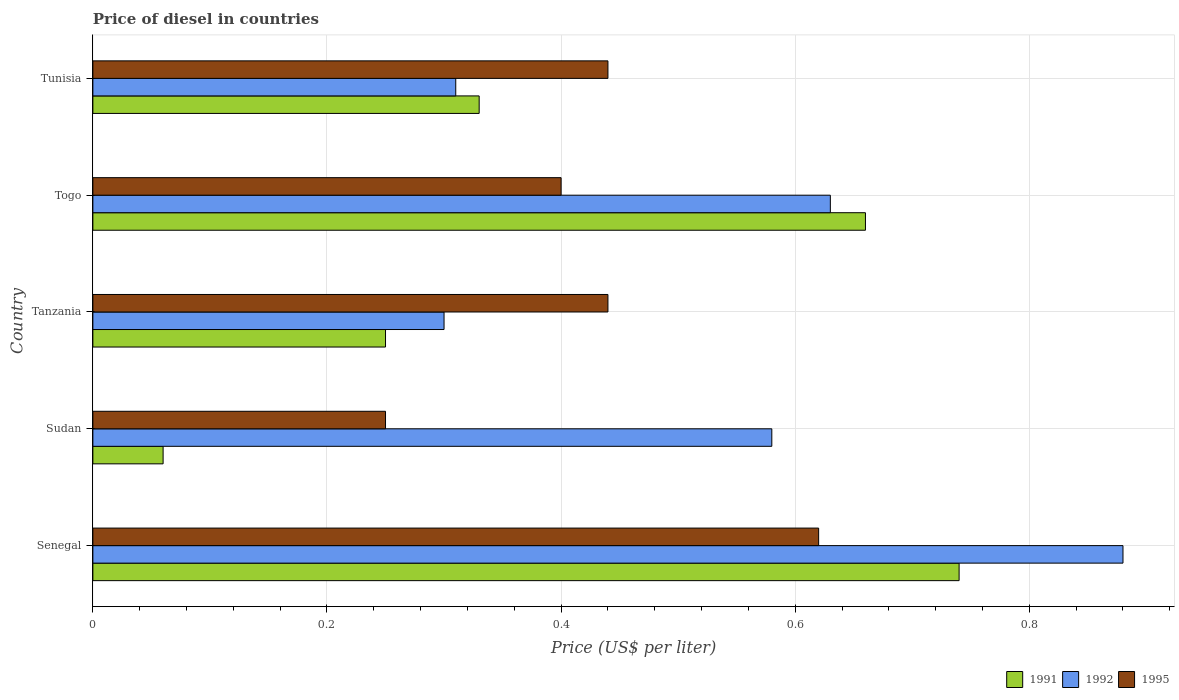How many different coloured bars are there?
Your response must be concise. 3. How many groups of bars are there?
Provide a succinct answer. 5. Are the number of bars per tick equal to the number of legend labels?
Your response must be concise. Yes. How many bars are there on the 1st tick from the bottom?
Give a very brief answer. 3. What is the label of the 1st group of bars from the top?
Offer a terse response. Tunisia. In how many cases, is the number of bars for a given country not equal to the number of legend labels?
Offer a very short reply. 0. What is the price of diesel in 1995 in Senegal?
Your answer should be very brief. 0.62. Across all countries, what is the maximum price of diesel in 1992?
Ensure brevity in your answer.  0.88. Across all countries, what is the minimum price of diesel in 1995?
Provide a short and direct response. 0.25. In which country was the price of diesel in 1992 maximum?
Your response must be concise. Senegal. In which country was the price of diesel in 1991 minimum?
Provide a short and direct response. Sudan. What is the total price of diesel in 1995 in the graph?
Offer a very short reply. 2.15. What is the difference between the price of diesel in 1992 in Senegal and that in Tanzania?
Offer a terse response. 0.58. What is the difference between the price of diesel in 1995 in Tunisia and the price of diesel in 1992 in Tanzania?
Your response must be concise. 0.14. What is the average price of diesel in 1992 per country?
Offer a very short reply. 0.54. What is the difference between the price of diesel in 1992 and price of diesel in 1991 in Sudan?
Provide a short and direct response. 0.52. What is the ratio of the price of diesel in 1995 in Sudan to that in Tunisia?
Ensure brevity in your answer.  0.57. Is the difference between the price of diesel in 1992 in Sudan and Tunisia greater than the difference between the price of diesel in 1991 in Sudan and Tunisia?
Provide a succinct answer. Yes. What is the difference between the highest and the second highest price of diesel in 1991?
Offer a very short reply. 0.08. What is the difference between the highest and the lowest price of diesel in 1992?
Offer a very short reply. 0.58. What does the 2nd bar from the top in Sudan represents?
Provide a succinct answer. 1992. What does the 3rd bar from the bottom in Sudan represents?
Offer a very short reply. 1995. Is it the case that in every country, the sum of the price of diesel in 1991 and price of diesel in 1992 is greater than the price of diesel in 1995?
Give a very brief answer. Yes. How many bars are there?
Ensure brevity in your answer.  15. Are all the bars in the graph horizontal?
Your answer should be very brief. Yes. How many countries are there in the graph?
Provide a succinct answer. 5. What is the difference between two consecutive major ticks on the X-axis?
Give a very brief answer. 0.2. Are the values on the major ticks of X-axis written in scientific E-notation?
Your response must be concise. No. Where does the legend appear in the graph?
Keep it short and to the point. Bottom right. How are the legend labels stacked?
Offer a very short reply. Horizontal. What is the title of the graph?
Keep it short and to the point. Price of diesel in countries. Does "1989" appear as one of the legend labels in the graph?
Your answer should be compact. No. What is the label or title of the X-axis?
Make the answer very short. Price (US$ per liter). What is the label or title of the Y-axis?
Give a very brief answer. Country. What is the Price (US$ per liter) in 1991 in Senegal?
Keep it short and to the point. 0.74. What is the Price (US$ per liter) of 1995 in Senegal?
Give a very brief answer. 0.62. What is the Price (US$ per liter) in 1992 in Sudan?
Keep it short and to the point. 0.58. What is the Price (US$ per liter) of 1991 in Tanzania?
Make the answer very short. 0.25. What is the Price (US$ per liter) of 1992 in Tanzania?
Offer a very short reply. 0.3. What is the Price (US$ per liter) in 1995 in Tanzania?
Your response must be concise. 0.44. What is the Price (US$ per liter) of 1991 in Togo?
Your response must be concise. 0.66. What is the Price (US$ per liter) of 1992 in Togo?
Make the answer very short. 0.63. What is the Price (US$ per liter) in 1991 in Tunisia?
Your response must be concise. 0.33. What is the Price (US$ per liter) in 1992 in Tunisia?
Provide a succinct answer. 0.31. What is the Price (US$ per liter) in 1995 in Tunisia?
Offer a terse response. 0.44. Across all countries, what is the maximum Price (US$ per liter) of 1991?
Keep it short and to the point. 0.74. Across all countries, what is the maximum Price (US$ per liter) of 1995?
Ensure brevity in your answer.  0.62. Across all countries, what is the minimum Price (US$ per liter) in 1991?
Your answer should be compact. 0.06. What is the total Price (US$ per liter) in 1991 in the graph?
Provide a short and direct response. 2.04. What is the total Price (US$ per liter) in 1995 in the graph?
Provide a short and direct response. 2.15. What is the difference between the Price (US$ per liter) in 1991 in Senegal and that in Sudan?
Provide a succinct answer. 0.68. What is the difference between the Price (US$ per liter) of 1992 in Senegal and that in Sudan?
Provide a short and direct response. 0.3. What is the difference between the Price (US$ per liter) of 1995 in Senegal and that in Sudan?
Keep it short and to the point. 0.37. What is the difference between the Price (US$ per liter) of 1991 in Senegal and that in Tanzania?
Offer a very short reply. 0.49. What is the difference between the Price (US$ per liter) in 1992 in Senegal and that in Tanzania?
Provide a succinct answer. 0.58. What is the difference between the Price (US$ per liter) in 1995 in Senegal and that in Tanzania?
Give a very brief answer. 0.18. What is the difference between the Price (US$ per liter) of 1991 in Senegal and that in Togo?
Your response must be concise. 0.08. What is the difference between the Price (US$ per liter) of 1992 in Senegal and that in Togo?
Keep it short and to the point. 0.25. What is the difference between the Price (US$ per liter) of 1995 in Senegal and that in Togo?
Your answer should be compact. 0.22. What is the difference between the Price (US$ per liter) of 1991 in Senegal and that in Tunisia?
Keep it short and to the point. 0.41. What is the difference between the Price (US$ per liter) in 1992 in Senegal and that in Tunisia?
Ensure brevity in your answer.  0.57. What is the difference between the Price (US$ per liter) in 1995 in Senegal and that in Tunisia?
Your answer should be very brief. 0.18. What is the difference between the Price (US$ per liter) in 1991 in Sudan and that in Tanzania?
Ensure brevity in your answer.  -0.19. What is the difference between the Price (US$ per liter) in 1992 in Sudan and that in Tanzania?
Make the answer very short. 0.28. What is the difference between the Price (US$ per liter) in 1995 in Sudan and that in Tanzania?
Keep it short and to the point. -0.19. What is the difference between the Price (US$ per liter) in 1991 in Sudan and that in Togo?
Provide a short and direct response. -0.6. What is the difference between the Price (US$ per liter) of 1992 in Sudan and that in Togo?
Give a very brief answer. -0.05. What is the difference between the Price (US$ per liter) in 1991 in Sudan and that in Tunisia?
Your answer should be compact. -0.27. What is the difference between the Price (US$ per liter) in 1992 in Sudan and that in Tunisia?
Keep it short and to the point. 0.27. What is the difference between the Price (US$ per liter) of 1995 in Sudan and that in Tunisia?
Give a very brief answer. -0.19. What is the difference between the Price (US$ per liter) in 1991 in Tanzania and that in Togo?
Your response must be concise. -0.41. What is the difference between the Price (US$ per liter) in 1992 in Tanzania and that in Togo?
Provide a short and direct response. -0.33. What is the difference between the Price (US$ per liter) in 1991 in Tanzania and that in Tunisia?
Ensure brevity in your answer.  -0.08. What is the difference between the Price (US$ per liter) in 1992 in Tanzania and that in Tunisia?
Your answer should be very brief. -0.01. What is the difference between the Price (US$ per liter) in 1995 in Tanzania and that in Tunisia?
Make the answer very short. 0. What is the difference between the Price (US$ per liter) in 1991 in Togo and that in Tunisia?
Offer a terse response. 0.33. What is the difference between the Price (US$ per liter) of 1992 in Togo and that in Tunisia?
Make the answer very short. 0.32. What is the difference between the Price (US$ per liter) in 1995 in Togo and that in Tunisia?
Make the answer very short. -0.04. What is the difference between the Price (US$ per liter) in 1991 in Senegal and the Price (US$ per liter) in 1992 in Sudan?
Your answer should be compact. 0.16. What is the difference between the Price (US$ per liter) of 1991 in Senegal and the Price (US$ per liter) of 1995 in Sudan?
Make the answer very short. 0.49. What is the difference between the Price (US$ per liter) of 1992 in Senegal and the Price (US$ per liter) of 1995 in Sudan?
Keep it short and to the point. 0.63. What is the difference between the Price (US$ per liter) of 1991 in Senegal and the Price (US$ per liter) of 1992 in Tanzania?
Offer a very short reply. 0.44. What is the difference between the Price (US$ per liter) in 1991 in Senegal and the Price (US$ per liter) in 1995 in Tanzania?
Your response must be concise. 0.3. What is the difference between the Price (US$ per liter) of 1992 in Senegal and the Price (US$ per liter) of 1995 in Tanzania?
Offer a very short reply. 0.44. What is the difference between the Price (US$ per liter) of 1991 in Senegal and the Price (US$ per liter) of 1992 in Togo?
Keep it short and to the point. 0.11. What is the difference between the Price (US$ per liter) of 1991 in Senegal and the Price (US$ per liter) of 1995 in Togo?
Your answer should be compact. 0.34. What is the difference between the Price (US$ per liter) of 1992 in Senegal and the Price (US$ per liter) of 1995 in Togo?
Keep it short and to the point. 0.48. What is the difference between the Price (US$ per liter) of 1991 in Senegal and the Price (US$ per liter) of 1992 in Tunisia?
Your response must be concise. 0.43. What is the difference between the Price (US$ per liter) in 1991 in Senegal and the Price (US$ per liter) in 1995 in Tunisia?
Offer a very short reply. 0.3. What is the difference between the Price (US$ per liter) in 1992 in Senegal and the Price (US$ per liter) in 1995 in Tunisia?
Make the answer very short. 0.44. What is the difference between the Price (US$ per liter) in 1991 in Sudan and the Price (US$ per liter) in 1992 in Tanzania?
Provide a succinct answer. -0.24. What is the difference between the Price (US$ per liter) of 1991 in Sudan and the Price (US$ per liter) of 1995 in Tanzania?
Provide a short and direct response. -0.38. What is the difference between the Price (US$ per liter) of 1992 in Sudan and the Price (US$ per liter) of 1995 in Tanzania?
Keep it short and to the point. 0.14. What is the difference between the Price (US$ per liter) in 1991 in Sudan and the Price (US$ per liter) in 1992 in Togo?
Make the answer very short. -0.57. What is the difference between the Price (US$ per liter) of 1991 in Sudan and the Price (US$ per liter) of 1995 in Togo?
Your answer should be compact. -0.34. What is the difference between the Price (US$ per liter) of 1992 in Sudan and the Price (US$ per liter) of 1995 in Togo?
Your response must be concise. 0.18. What is the difference between the Price (US$ per liter) in 1991 in Sudan and the Price (US$ per liter) in 1992 in Tunisia?
Provide a succinct answer. -0.25. What is the difference between the Price (US$ per liter) of 1991 in Sudan and the Price (US$ per liter) of 1995 in Tunisia?
Provide a succinct answer. -0.38. What is the difference between the Price (US$ per liter) in 1992 in Sudan and the Price (US$ per liter) in 1995 in Tunisia?
Offer a terse response. 0.14. What is the difference between the Price (US$ per liter) in 1991 in Tanzania and the Price (US$ per liter) in 1992 in Togo?
Offer a terse response. -0.38. What is the difference between the Price (US$ per liter) of 1991 in Tanzania and the Price (US$ per liter) of 1995 in Togo?
Your answer should be compact. -0.15. What is the difference between the Price (US$ per liter) of 1991 in Tanzania and the Price (US$ per liter) of 1992 in Tunisia?
Your answer should be compact. -0.06. What is the difference between the Price (US$ per liter) of 1991 in Tanzania and the Price (US$ per liter) of 1995 in Tunisia?
Offer a terse response. -0.19. What is the difference between the Price (US$ per liter) in 1992 in Tanzania and the Price (US$ per liter) in 1995 in Tunisia?
Provide a succinct answer. -0.14. What is the difference between the Price (US$ per liter) in 1991 in Togo and the Price (US$ per liter) in 1992 in Tunisia?
Keep it short and to the point. 0.35. What is the difference between the Price (US$ per liter) in 1991 in Togo and the Price (US$ per liter) in 1995 in Tunisia?
Provide a short and direct response. 0.22. What is the difference between the Price (US$ per liter) of 1992 in Togo and the Price (US$ per liter) of 1995 in Tunisia?
Your answer should be compact. 0.19. What is the average Price (US$ per liter) of 1991 per country?
Give a very brief answer. 0.41. What is the average Price (US$ per liter) of 1992 per country?
Provide a short and direct response. 0.54. What is the average Price (US$ per liter) in 1995 per country?
Offer a very short reply. 0.43. What is the difference between the Price (US$ per liter) in 1991 and Price (US$ per liter) in 1992 in Senegal?
Your response must be concise. -0.14. What is the difference between the Price (US$ per liter) of 1991 and Price (US$ per liter) of 1995 in Senegal?
Offer a very short reply. 0.12. What is the difference between the Price (US$ per liter) of 1992 and Price (US$ per liter) of 1995 in Senegal?
Provide a succinct answer. 0.26. What is the difference between the Price (US$ per liter) in 1991 and Price (US$ per liter) in 1992 in Sudan?
Provide a succinct answer. -0.52. What is the difference between the Price (US$ per liter) in 1991 and Price (US$ per liter) in 1995 in Sudan?
Offer a terse response. -0.19. What is the difference between the Price (US$ per liter) of 1992 and Price (US$ per liter) of 1995 in Sudan?
Give a very brief answer. 0.33. What is the difference between the Price (US$ per liter) of 1991 and Price (US$ per liter) of 1995 in Tanzania?
Your answer should be very brief. -0.19. What is the difference between the Price (US$ per liter) of 1992 and Price (US$ per liter) of 1995 in Tanzania?
Offer a terse response. -0.14. What is the difference between the Price (US$ per liter) in 1991 and Price (US$ per liter) in 1995 in Togo?
Ensure brevity in your answer.  0.26. What is the difference between the Price (US$ per liter) in 1992 and Price (US$ per liter) in 1995 in Togo?
Provide a succinct answer. 0.23. What is the difference between the Price (US$ per liter) in 1991 and Price (US$ per liter) in 1995 in Tunisia?
Your response must be concise. -0.11. What is the difference between the Price (US$ per liter) of 1992 and Price (US$ per liter) of 1995 in Tunisia?
Offer a very short reply. -0.13. What is the ratio of the Price (US$ per liter) in 1991 in Senegal to that in Sudan?
Make the answer very short. 12.33. What is the ratio of the Price (US$ per liter) of 1992 in Senegal to that in Sudan?
Make the answer very short. 1.52. What is the ratio of the Price (US$ per liter) of 1995 in Senegal to that in Sudan?
Make the answer very short. 2.48. What is the ratio of the Price (US$ per liter) in 1991 in Senegal to that in Tanzania?
Provide a short and direct response. 2.96. What is the ratio of the Price (US$ per liter) of 1992 in Senegal to that in Tanzania?
Keep it short and to the point. 2.93. What is the ratio of the Price (US$ per liter) of 1995 in Senegal to that in Tanzania?
Provide a short and direct response. 1.41. What is the ratio of the Price (US$ per liter) of 1991 in Senegal to that in Togo?
Provide a short and direct response. 1.12. What is the ratio of the Price (US$ per liter) in 1992 in Senegal to that in Togo?
Your answer should be compact. 1.4. What is the ratio of the Price (US$ per liter) in 1995 in Senegal to that in Togo?
Your answer should be compact. 1.55. What is the ratio of the Price (US$ per liter) of 1991 in Senegal to that in Tunisia?
Make the answer very short. 2.24. What is the ratio of the Price (US$ per liter) in 1992 in Senegal to that in Tunisia?
Ensure brevity in your answer.  2.84. What is the ratio of the Price (US$ per liter) of 1995 in Senegal to that in Tunisia?
Your answer should be very brief. 1.41. What is the ratio of the Price (US$ per liter) of 1991 in Sudan to that in Tanzania?
Your answer should be very brief. 0.24. What is the ratio of the Price (US$ per liter) of 1992 in Sudan to that in Tanzania?
Offer a very short reply. 1.93. What is the ratio of the Price (US$ per liter) in 1995 in Sudan to that in Tanzania?
Provide a short and direct response. 0.57. What is the ratio of the Price (US$ per liter) in 1991 in Sudan to that in Togo?
Offer a terse response. 0.09. What is the ratio of the Price (US$ per liter) in 1992 in Sudan to that in Togo?
Offer a very short reply. 0.92. What is the ratio of the Price (US$ per liter) in 1991 in Sudan to that in Tunisia?
Ensure brevity in your answer.  0.18. What is the ratio of the Price (US$ per liter) in 1992 in Sudan to that in Tunisia?
Give a very brief answer. 1.87. What is the ratio of the Price (US$ per liter) in 1995 in Sudan to that in Tunisia?
Provide a succinct answer. 0.57. What is the ratio of the Price (US$ per liter) of 1991 in Tanzania to that in Togo?
Make the answer very short. 0.38. What is the ratio of the Price (US$ per liter) in 1992 in Tanzania to that in Togo?
Your answer should be very brief. 0.48. What is the ratio of the Price (US$ per liter) in 1991 in Tanzania to that in Tunisia?
Provide a short and direct response. 0.76. What is the ratio of the Price (US$ per liter) of 1995 in Tanzania to that in Tunisia?
Your answer should be compact. 1. What is the ratio of the Price (US$ per liter) of 1991 in Togo to that in Tunisia?
Offer a terse response. 2. What is the ratio of the Price (US$ per liter) in 1992 in Togo to that in Tunisia?
Give a very brief answer. 2.03. What is the ratio of the Price (US$ per liter) of 1995 in Togo to that in Tunisia?
Provide a short and direct response. 0.91. What is the difference between the highest and the second highest Price (US$ per liter) of 1992?
Keep it short and to the point. 0.25. What is the difference between the highest and the second highest Price (US$ per liter) of 1995?
Provide a succinct answer. 0.18. What is the difference between the highest and the lowest Price (US$ per liter) of 1991?
Offer a terse response. 0.68. What is the difference between the highest and the lowest Price (US$ per liter) of 1992?
Offer a very short reply. 0.58. What is the difference between the highest and the lowest Price (US$ per liter) of 1995?
Provide a succinct answer. 0.37. 